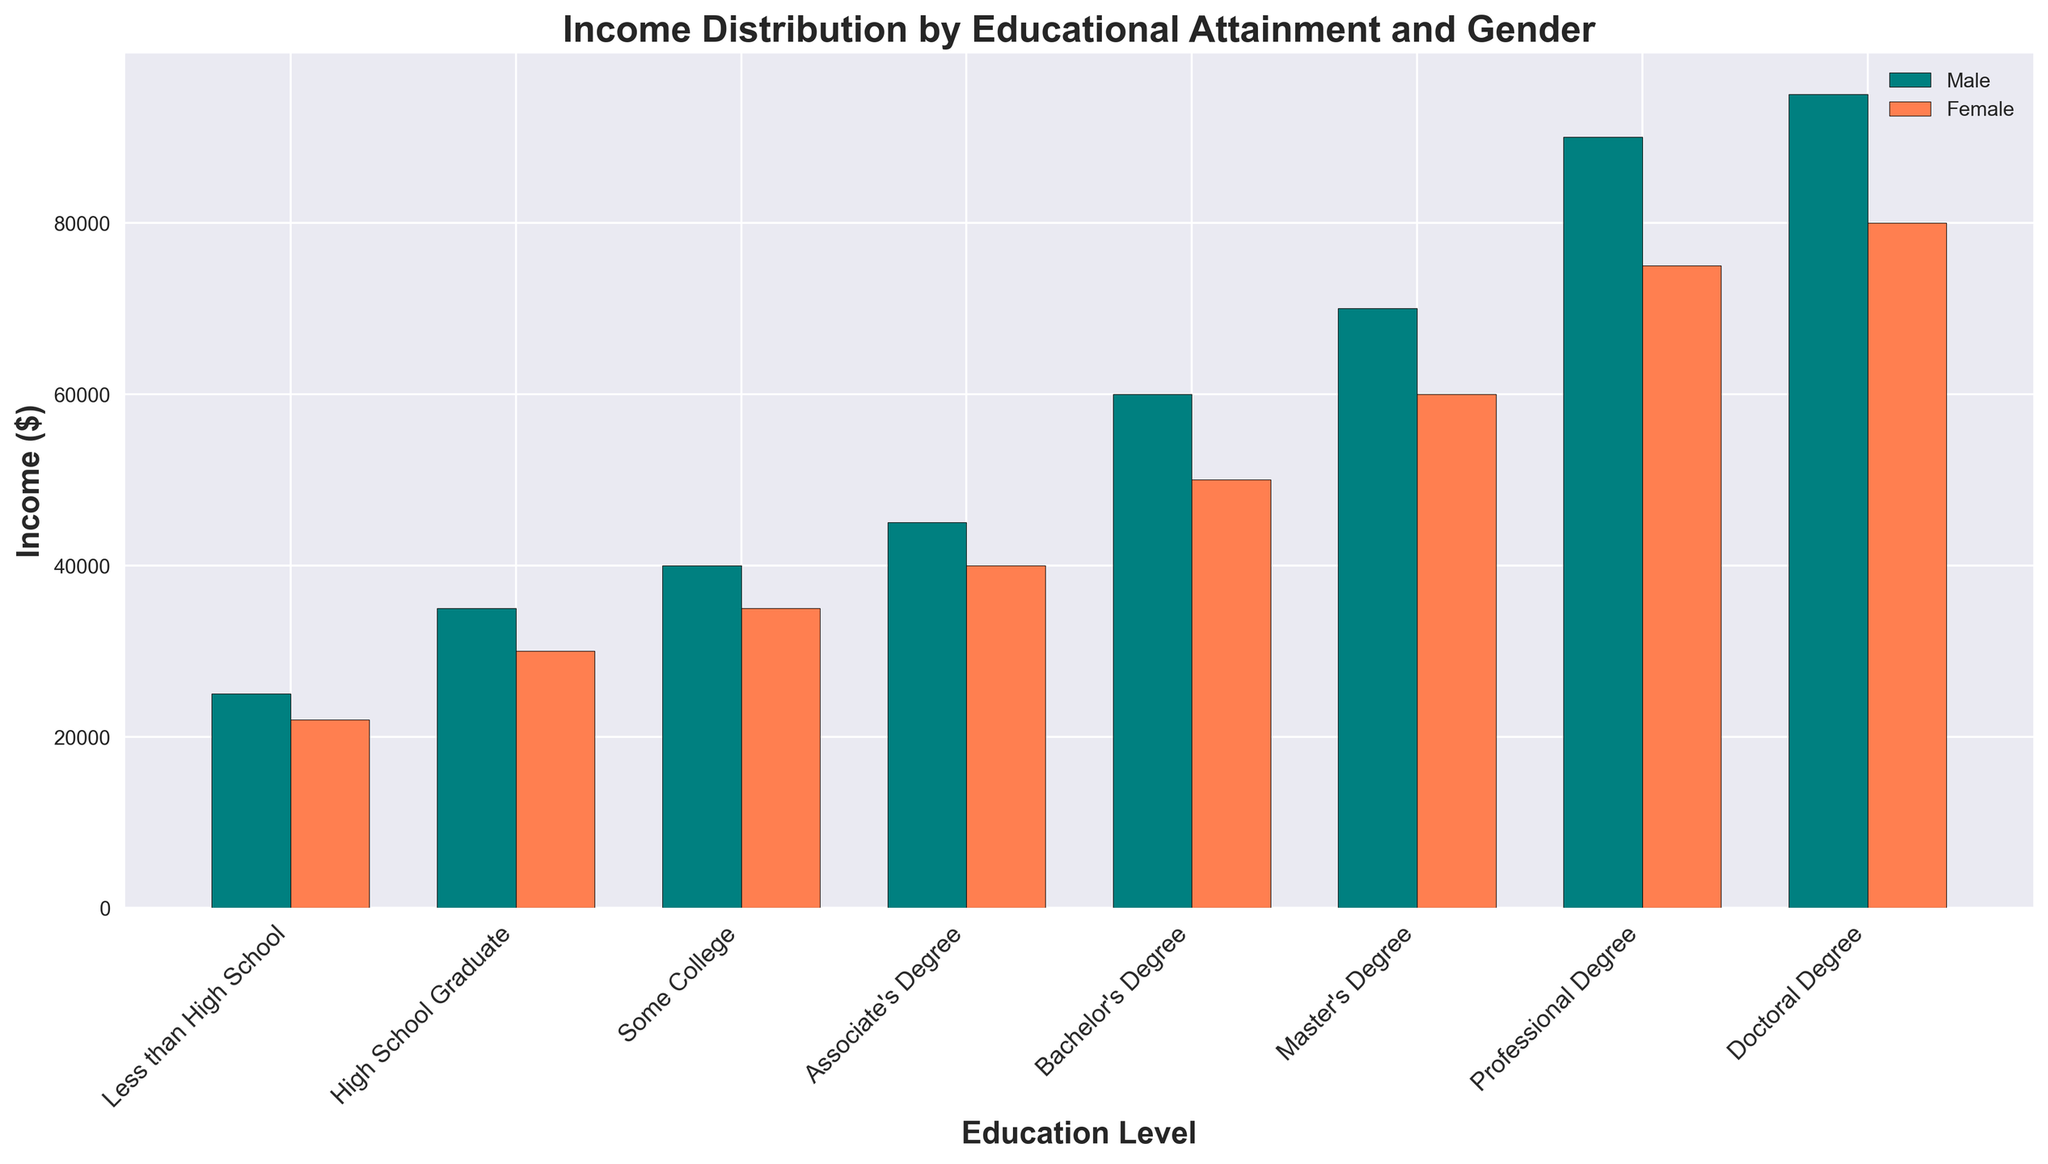What is the income difference between males and females with a Bachelor's Degree? First, locate the bars for Bachelor's Degree. The male income is $60,000, and the female income is $50,000. Subtract the female income from the male income: $60,000 - $50,000.
Answer: $10,000 Which gender has the higher income for each educational level? Compare the height of the bars for each educational level. For all levels, the male bar is taller than the female bar, indicating that males have higher incomes across all levels: Less than High School, High School Graduate, Some College, Associate's Degree, Bachelor's Degree, Master's Degree, Professional Degree, and Doctoral Degree.
Answer: Male Which gender has the greatest income for a Doctoral Degree? Find the bars for Doctoral Degree. The male income bar is higher than the female one, representing $95,000 for males and $80,000 for females. Therefore, males have the greatest income.
Answer: Male What is the total income for females with a Master's Degree and a Professional Degree? Identify the incomes for females with a Master's Degree ($60,000) and a Professional Degree ($75,000). Sum them up: $60,000 + $75,000.
Answer: $135,000 What is the visual difference in bar color between males and females? The bars representing males are teal, while the bars representing females are coral.
Answer: Males: teal, Females: coral How does the income for males with some college compare to females with a Bachelor's Degree? The bar for males with Some College shows $40,000, while the bar for females with a Bachelor's Degree shows $50,000. The females with a Bachelor's Degree earn more than males with Some College.
Answer: Females with Bachelor's Degree earn more Which educational level shows the smallest income difference between males and females? Calculate the income differences for each educational level:
- Less than High School: $3,000
- High School Graduate: $5,000
- Some College: $5,000
- Associate's Degree: $5,000
- Bachelor's Degree: $10,000
- Master's Degree: $10,000
- Professional Degree: $15,000
- Doctoral Degree: $15,000
The smallest difference is for Less than High School.
Answer: Less than High School What is the income for females with an Associate's Degree? Locate the bar for females with an Associate's Degree, which shows an income of $40,000.
Answer: $40,000 What is the average income for males across all education levels? Sum the incomes for males: $25,000 + $35,000 + $40,000 + $45,000 + $60,000 + $70,000 + $90,000 + $95,000 = $460,000. Divide by the number of levels (8): $460,000 / 8.
Answer: $57,500 